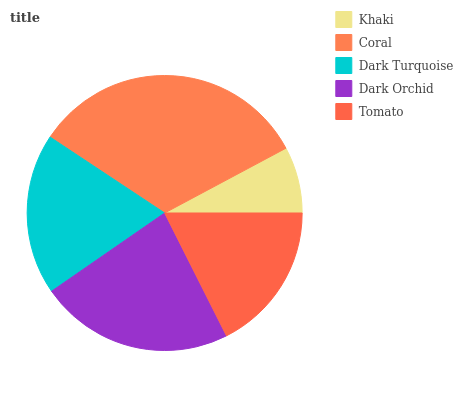Is Khaki the minimum?
Answer yes or no. Yes. Is Coral the maximum?
Answer yes or no. Yes. Is Dark Turquoise the minimum?
Answer yes or no. No. Is Dark Turquoise the maximum?
Answer yes or no. No. Is Coral greater than Dark Turquoise?
Answer yes or no. Yes. Is Dark Turquoise less than Coral?
Answer yes or no. Yes. Is Dark Turquoise greater than Coral?
Answer yes or no. No. Is Coral less than Dark Turquoise?
Answer yes or no. No. Is Dark Turquoise the high median?
Answer yes or no. Yes. Is Dark Turquoise the low median?
Answer yes or no. Yes. Is Khaki the high median?
Answer yes or no. No. Is Khaki the low median?
Answer yes or no. No. 